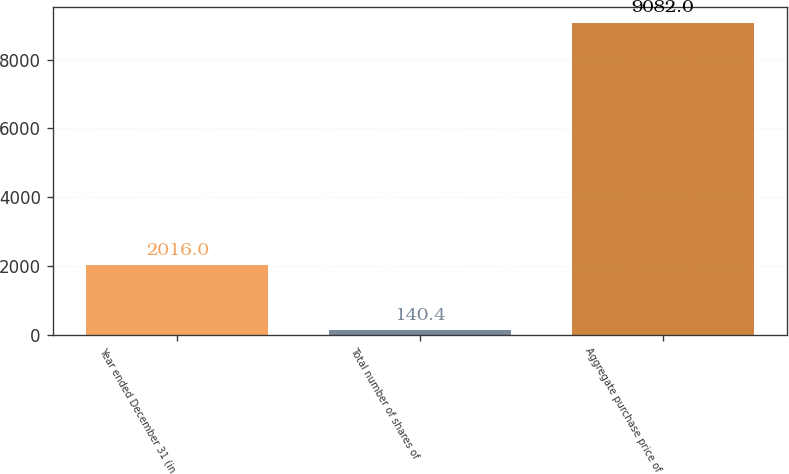Convert chart to OTSL. <chart><loc_0><loc_0><loc_500><loc_500><bar_chart><fcel>Year ended December 31 (in<fcel>Total number of shares of<fcel>Aggregate purchase price of<nl><fcel>2016<fcel>140.4<fcel>9082<nl></chart> 